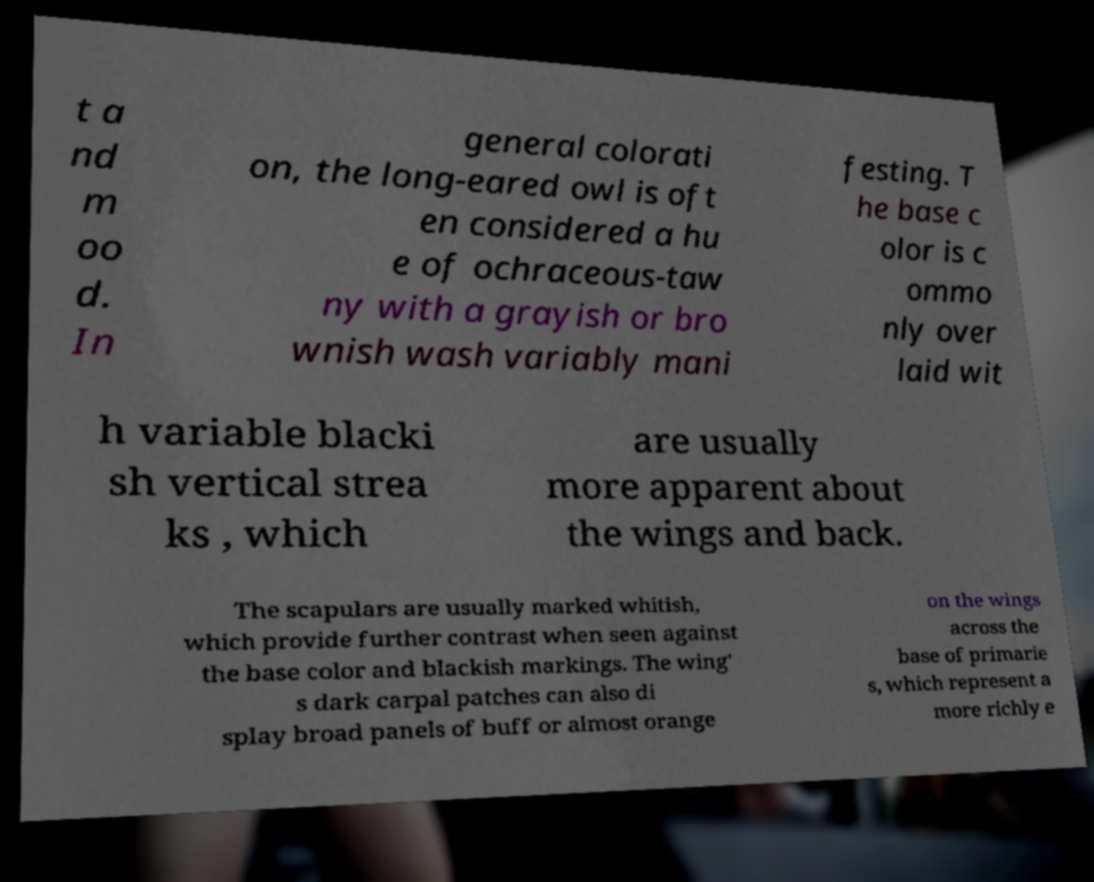Please read and relay the text visible in this image. What does it say? t a nd m oo d. In general colorati on, the long-eared owl is oft en considered a hu e of ochraceous-taw ny with a grayish or bro wnish wash variably mani festing. T he base c olor is c ommo nly over laid wit h variable blacki sh vertical strea ks , which are usually more apparent about the wings and back. The scapulars are usually marked whitish, which provide further contrast when seen against the base color and blackish markings. The wing' s dark carpal patches can also di splay broad panels of buff or almost orange on the wings across the base of primarie s, which represent a more richly e 